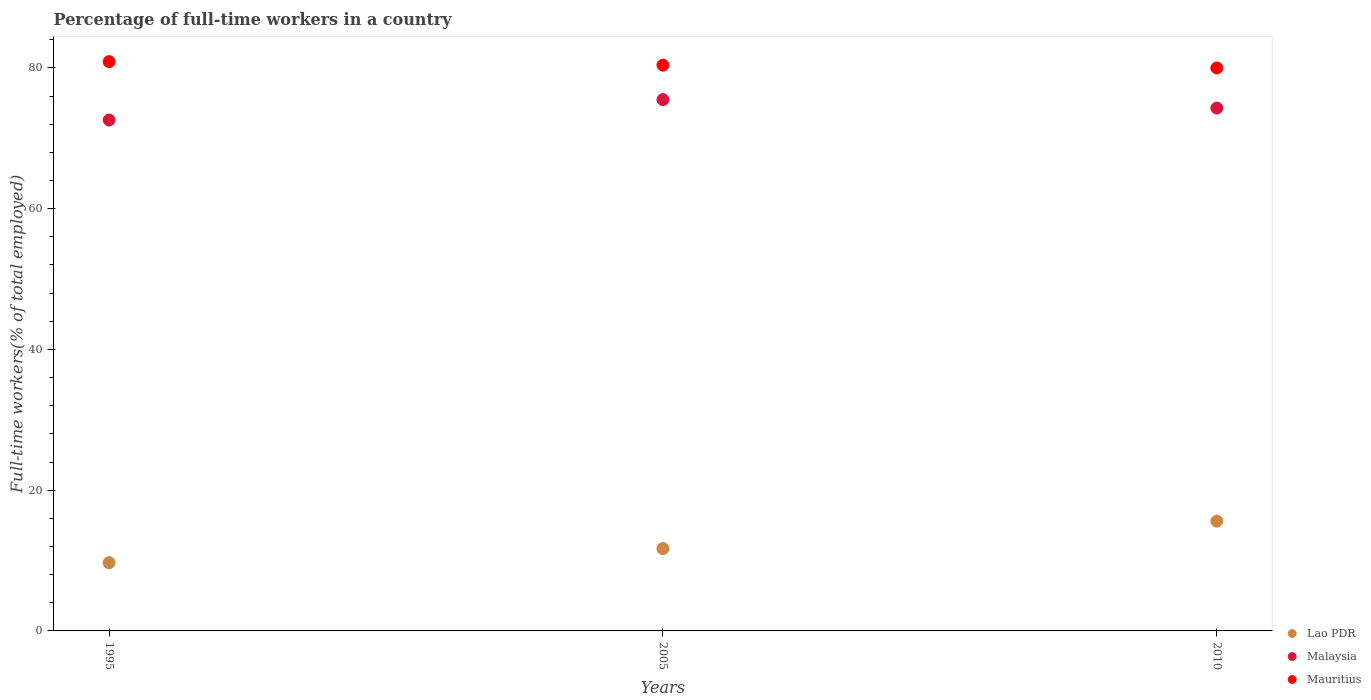Is the number of dotlines equal to the number of legend labels?
Offer a terse response. Yes. What is the percentage of full-time workers in Malaysia in 2005?
Keep it short and to the point. 75.5. Across all years, what is the maximum percentage of full-time workers in Mauritius?
Make the answer very short. 80.9. Across all years, what is the minimum percentage of full-time workers in Lao PDR?
Provide a succinct answer. 9.7. In which year was the percentage of full-time workers in Mauritius minimum?
Your response must be concise. 2010. What is the total percentage of full-time workers in Malaysia in the graph?
Your answer should be very brief. 222.4. What is the difference between the percentage of full-time workers in Malaysia in 2005 and that in 2010?
Offer a terse response. 1.2. What is the difference between the percentage of full-time workers in Malaysia in 1995 and the percentage of full-time workers in Lao PDR in 2010?
Provide a short and direct response. 57. What is the average percentage of full-time workers in Lao PDR per year?
Your answer should be compact. 12.33. In the year 2010, what is the difference between the percentage of full-time workers in Malaysia and percentage of full-time workers in Mauritius?
Offer a terse response. -5.7. In how many years, is the percentage of full-time workers in Malaysia greater than 44 %?
Give a very brief answer. 3. What is the ratio of the percentage of full-time workers in Lao PDR in 2005 to that in 2010?
Your response must be concise. 0.75. What is the difference between the highest and the second highest percentage of full-time workers in Mauritius?
Provide a short and direct response. 0.5. What is the difference between the highest and the lowest percentage of full-time workers in Mauritius?
Offer a terse response. 0.9. Is the sum of the percentage of full-time workers in Mauritius in 1995 and 2010 greater than the maximum percentage of full-time workers in Malaysia across all years?
Make the answer very short. Yes. Is it the case that in every year, the sum of the percentage of full-time workers in Malaysia and percentage of full-time workers in Mauritius  is greater than the percentage of full-time workers in Lao PDR?
Give a very brief answer. Yes. Is the percentage of full-time workers in Mauritius strictly less than the percentage of full-time workers in Malaysia over the years?
Ensure brevity in your answer.  No. What is the difference between two consecutive major ticks on the Y-axis?
Your answer should be very brief. 20. How many legend labels are there?
Provide a succinct answer. 3. What is the title of the graph?
Offer a very short reply. Percentage of full-time workers in a country. What is the label or title of the Y-axis?
Your response must be concise. Full-time workers(% of total employed). What is the Full-time workers(% of total employed) of Lao PDR in 1995?
Your answer should be compact. 9.7. What is the Full-time workers(% of total employed) in Malaysia in 1995?
Your response must be concise. 72.6. What is the Full-time workers(% of total employed) of Mauritius in 1995?
Provide a succinct answer. 80.9. What is the Full-time workers(% of total employed) in Lao PDR in 2005?
Ensure brevity in your answer.  11.7. What is the Full-time workers(% of total employed) in Malaysia in 2005?
Give a very brief answer. 75.5. What is the Full-time workers(% of total employed) in Mauritius in 2005?
Your response must be concise. 80.4. What is the Full-time workers(% of total employed) in Lao PDR in 2010?
Your answer should be compact. 15.6. What is the Full-time workers(% of total employed) of Malaysia in 2010?
Provide a succinct answer. 74.3. What is the Full-time workers(% of total employed) of Mauritius in 2010?
Your answer should be very brief. 80. Across all years, what is the maximum Full-time workers(% of total employed) of Lao PDR?
Your answer should be compact. 15.6. Across all years, what is the maximum Full-time workers(% of total employed) of Malaysia?
Provide a succinct answer. 75.5. Across all years, what is the maximum Full-time workers(% of total employed) of Mauritius?
Offer a very short reply. 80.9. Across all years, what is the minimum Full-time workers(% of total employed) of Lao PDR?
Offer a very short reply. 9.7. Across all years, what is the minimum Full-time workers(% of total employed) of Malaysia?
Offer a very short reply. 72.6. What is the total Full-time workers(% of total employed) in Malaysia in the graph?
Give a very brief answer. 222.4. What is the total Full-time workers(% of total employed) in Mauritius in the graph?
Make the answer very short. 241.3. What is the difference between the Full-time workers(% of total employed) of Malaysia in 1995 and that in 2010?
Provide a short and direct response. -1.7. What is the difference between the Full-time workers(% of total employed) in Mauritius in 1995 and that in 2010?
Offer a very short reply. 0.9. What is the difference between the Full-time workers(% of total employed) in Lao PDR in 2005 and that in 2010?
Your answer should be very brief. -3.9. What is the difference between the Full-time workers(% of total employed) in Lao PDR in 1995 and the Full-time workers(% of total employed) in Malaysia in 2005?
Your response must be concise. -65.8. What is the difference between the Full-time workers(% of total employed) of Lao PDR in 1995 and the Full-time workers(% of total employed) of Mauritius in 2005?
Provide a succinct answer. -70.7. What is the difference between the Full-time workers(% of total employed) in Malaysia in 1995 and the Full-time workers(% of total employed) in Mauritius in 2005?
Offer a very short reply. -7.8. What is the difference between the Full-time workers(% of total employed) in Lao PDR in 1995 and the Full-time workers(% of total employed) in Malaysia in 2010?
Your response must be concise. -64.6. What is the difference between the Full-time workers(% of total employed) in Lao PDR in 1995 and the Full-time workers(% of total employed) in Mauritius in 2010?
Your answer should be very brief. -70.3. What is the difference between the Full-time workers(% of total employed) in Lao PDR in 2005 and the Full-time workers(% of total employed) in Malaysia in 2010?
Your response must be concise. -62.6. What is the difference between the Full-time workers(% of total employed) of Lao PDR in 2005 and the Full-time workers(% of total employed) of Mauritius in 2010?
Your answer should be very brief. -68.3. What is the difference between the Full-time workers(% of total employed) of Malaysia in 2005 and the Full-time workers(% of total employed) of Mauritius in 2010?
Provide a succinct answer. -4.5. What is the average Full-time workers(% of total employed) of Lao PDR per year?
Provide a succinct answer. 12.33. What is the average Full-time workers(% of total employed) of Malaysia per year?
Your answer should be very brief. 74.13. What is the average Full-time workers(% of total employed) in Mauritius per year?
Offer a very short reply. 80.43. In the year 1995, what is the difference between the Full-time workers(% of total employed) of Lao PDR and Full-time workers(% of total employed) of Malaysia?
Give a very brief answer. -62.9. In the year 1995, what is the difference between the Full-time workers(% of total employed) in Lao PDR and Full-time workers(% of total employed) in Mauritius?
Make the answer very short. -71.2. In the year 1995, what is the difference between the Full-time workers(% of total employed) of Malaysia and Full-time workers(% of total employed) of Mauritius?
Your answer should be very brief. -8.3. In the year 2005, what is the difference between the Full-time workers(% of total employed) of Lao PDR and Full-time workers(% of total employed) of Malaysia?
Provide a succinct answer. -63.8. In the year 2005, what is the difference between the Full-time workers(% of total employed) in Lao PDR and Full-time workers(% of total employed) in Mauritius?
Offer a terse response. -68.7. In the year 2005, what is the difference between the Full-time workers(% of total employed) of Malaysia and Full-time workers(% of total employed) of Mauritius?
Offer a terse response. -4.9. In the year 2010, what is the difference between the Full-time workers(% of total employed) in Lao PDR and Full-time workers(% of total employed) in Malaysia?
Ensure brevity in your answer.  -58.7. In the year 2010, what is the difference between the Full-time workers(% of total employed) in Lao PDR and Full-time workers(% of total employed) in Mauritius?
Your answer should be compact. -64.4. In the year 2010, what is the difference between the Full-time workers(% of total employed) of Malaysia and Full-time workers(% of total employed) of Mauritius?
Make the answer very short. -5.7. What is the ratio of the Full-time workers(% of total employed) in Lao PDR in 1995 to that in 2005?
Your answer should be compact. 0.83. What is the ratio of the Full-time workers(% of total employed) in Malaysia in 1995 to that in 2005?
Provide a succinct answer. 0.96. What is the ratio of the Full-time workers(% of total employed) in Mauritius in 1995 to that in 2005?
Your answer should be very brief. 1.01. What is the ratio of the Full-time workers(% of total employed) in Lao PDR in 1995 to that in 2010?
Make the answer very short. 0.62. What is the ratio of the Full-time workers(% of total employed) in Malaysia in 1995 to that in 2010?
Offer a terse response. 0.98. What is the ratio of the Full-time workers(% of total employed) in Mauritius in 1995 to that in 2010?
Your response must be concise. 1.01. What is the ratio of the Full-time workers(% of total employed) in Malaysia in 2005 to that in 2010?
Offer a very short reply. 1.02. What is the ratio of the Full-time workers(% of total employed) in Mauritius in 2005 to that in 2010?
Your answer should be very brief. 1. What is the difference between the highest and the second highest Full-time workers(% of total employed) in Lao PDR?
Your response must be concise. 3.9. What is the difference between the highest and the second highest Full-time workers(% of total employed) of Malaysia?
Ensure brevity in your answer.  1.2. 